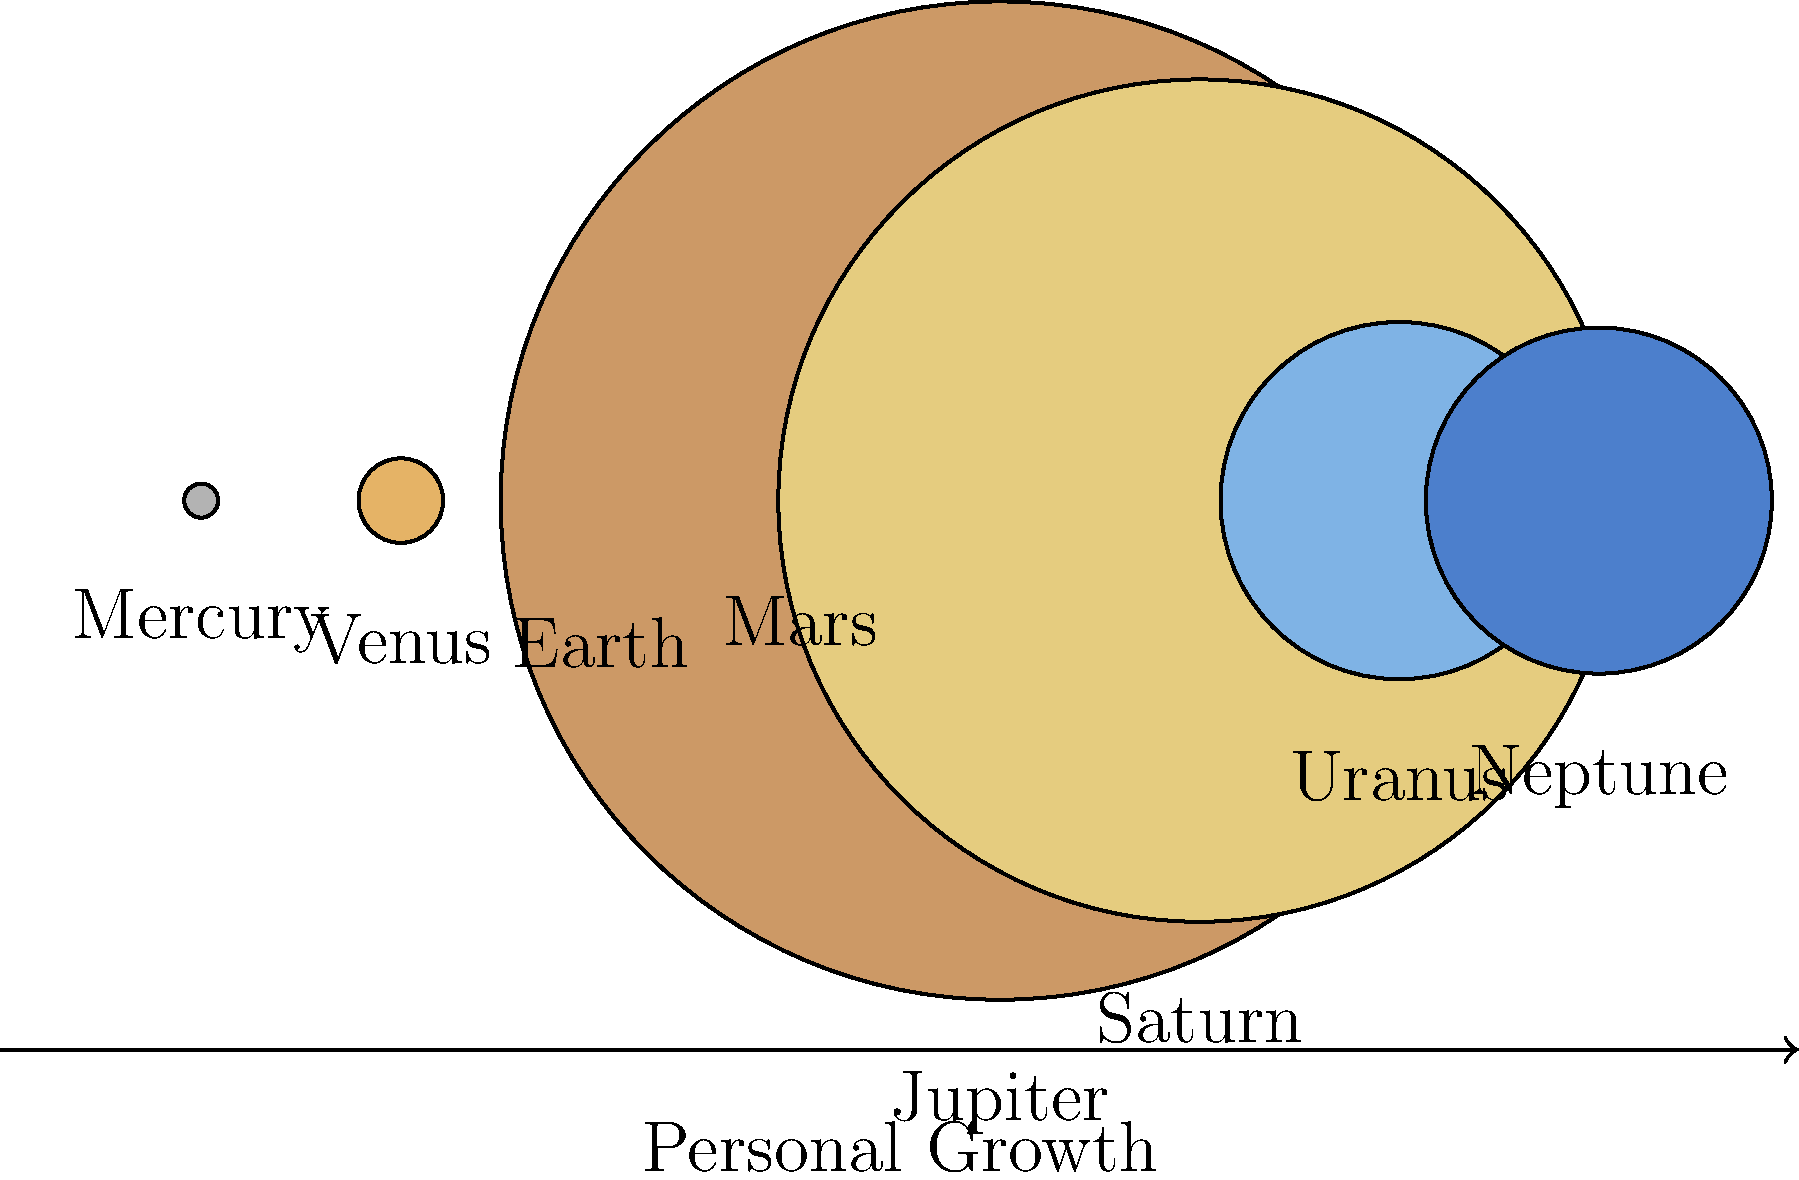In the context of personal growth and overcoming fears, how might the vast differences in planetary sizes in our solar system relate to an individual's journey of self-improvement? Consider Jupiter's immense size compared to Earth and the smaller inner planets. 1. Observe the relative sizes of the planets in the solar system as shown in the diagram. Jupiter, the largest planet, dwarfs the inner planets like Mercury, Venus, Earth, and Mars.

2. In personal growth:
   a) The small inner planets can represent an individual's initial state, with limited self-awareness and personal development.
   b) Jupiter's enormous size symbolizes the vast potential for growth and self-improvement that exists within each person.

3. The journey from Earth (representing one's current state) to Jupiter (representing full potential) involves:
   a) Recognizing one's current limitations (Earth's size)
   b) Acknowledging the immense possibilities for growth (Jupiter's size)
   c) Understanding that personal growth is a gradual process, like moving through the solar system

4. Overcoming fears and insecurities:
   a) Small planets (Mercury, Mars) can represent specific fears or insecurities
   b) Larger planets (Saturn, Uranus) can symbolize milestones in personal development
   c) Jupiter represents the ultimate goal of overcoming major life obstacles

5. The arrow labeled "Personal Growth" at the bottom of the diagram illustrates that progress is continuous and directional, much like moving outward through the solar system.

6. Just as each planet has its unique characteristics despite size differences, individuals have their own strengths and challenges in their personal growth journey.

7. The diversity in planetary sizes reminds us that growth and progress can come in various forms and magnitudes, encouraging patience and persistence in one's personal development.
Answer: Planetary size differences symbolize the vast potential for personal growth, with smaller planets representing current state or specific fears, and larger planets symbolizing milestones and ultimate goals in overcoming obstacles and achieving self-improvement. 